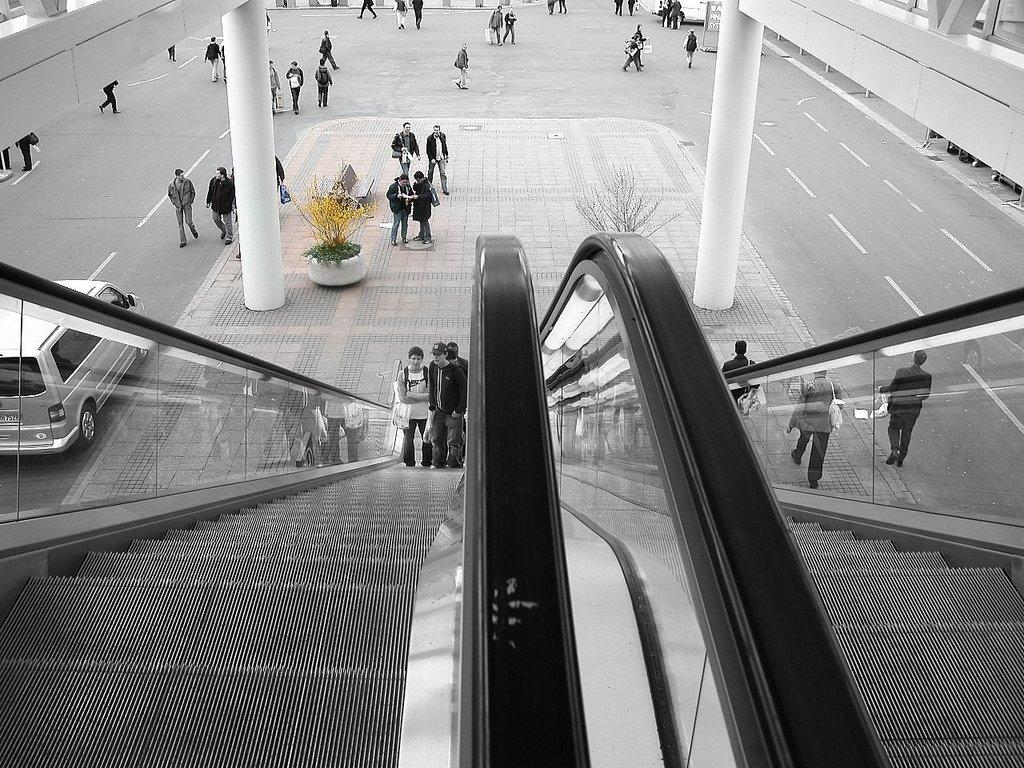What are the people doing in the center of the image? There are people on an escalator in the center of the image. What can be seen in the background of the image? There is a vehicle and many people on the road in the background of the image. Can you identify any other objects in the image? Yes, there is a flower pot visible in the image. What type of jelly can be seen on the escalator in the image? There is no jelly present on the escalator or in the image. Can you describe the behavior of the goose in the image? There is no goose present in the image. 